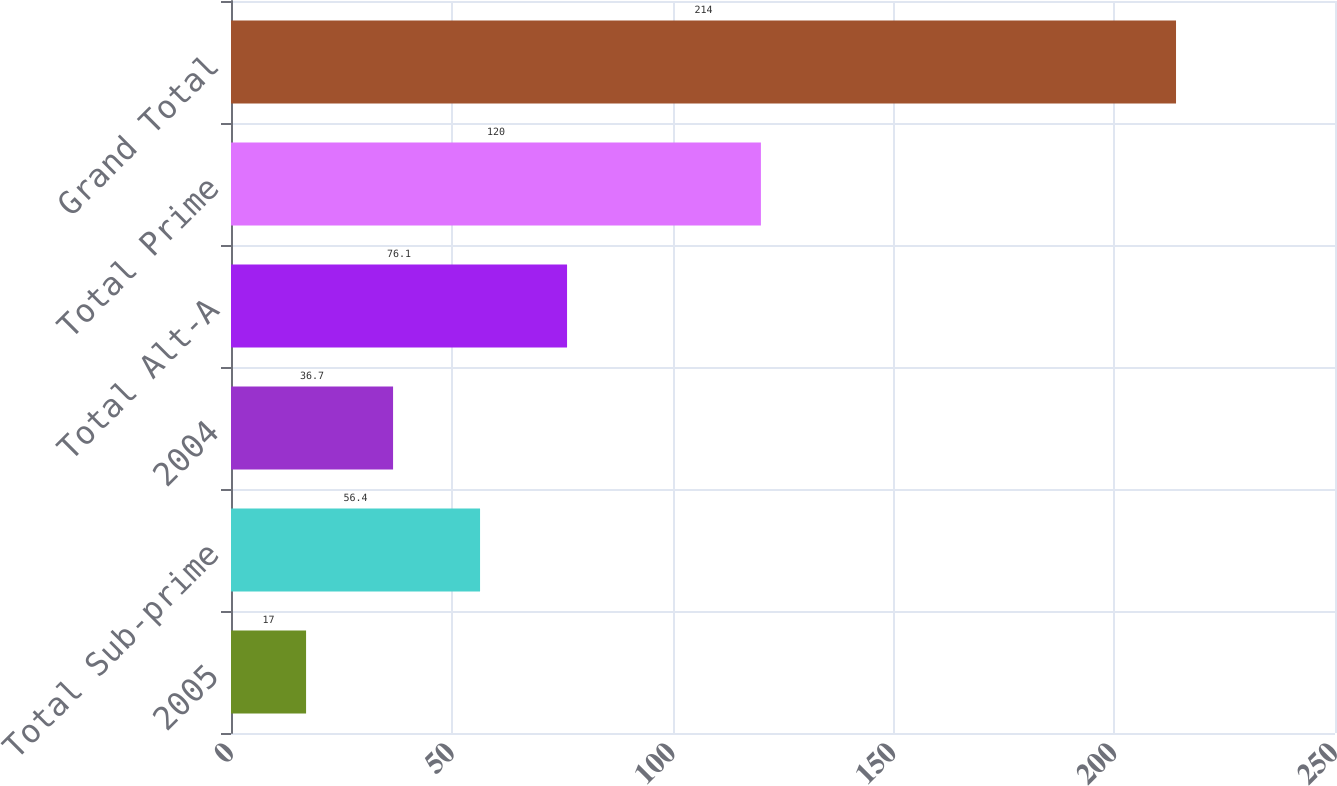Convert chart to OTSL. <chart><loc_0><loc_0><loc_500><loc_500><bar_chart><fcel>2005<fcel>Total Sub-prime<fcel>2004<fcel>Total Alt-A<fcel>Total Prime<fcel>Grand Total<nl><fcel>17<fcel>56.4<fcel>36.7<fcel>76.1<fcel>120<fcel>214<nl></chart> 